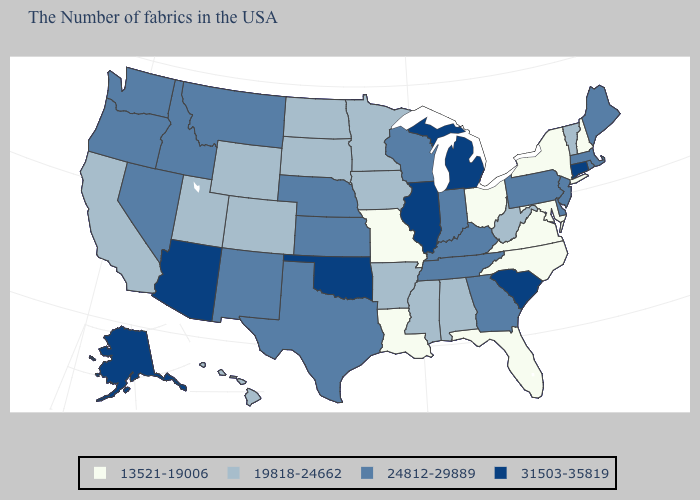Does California have the lowest value in the West?
Short answer required. Yes. Among the states that border Vermont , which have the highest value?
Answer briefly. Massachusetts. What is the value of Texas?
Concise answer only. 24812-29889. Does North Dakota have the lowest value in the MidWest?
Give a very brief answer. No. Which states have the lowest value in the Northeast?
Short answer required. New Hampshire, New York. Which states have the lowest value in the USA?
Concise answer only. New Hampshire, New York, Maryland, Virginia, North Carolina, Ohio, Florida, Louisiana, Missouri. What is the highest value in states that border Nebraska?
Concise answer only. 24812-29889. Name the states that have a value in the range 31503-35819?
Give a very brief answer. Connecticut, South Carolina, Michigan, Illinois, Oklahoma, Arizona, Alaska. Does the map have missing data?
Concise answer only. No. What is the value of Washington?
Short answer required. 24812-29889. What is the value of Minnesota?
Keep it brief. 19818-24662. Among the states that border West Virginia , which have the lowest value?
Write a very short answer. Maryland, Virginia, Ohio. Is the legend a continuous bar?
Short answer required. No. Which states have the highest value in the USA?
Be succinct. Connecticut, South Carolina, Michigan, Illinois, Oklahoma, Arizona, Alaska. Which states hav the highest value in the South?
Answer briefly. South Carolina, Oklahoma. 